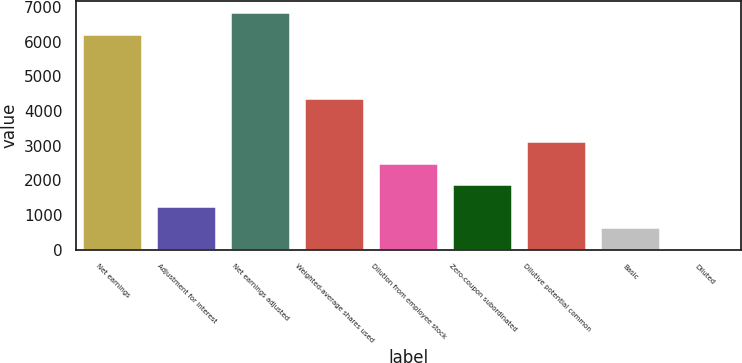Convert chart to OTSL. <chart><loc_0><loc_0><loc_500><loc_500><bar_chart><fcel>Net earnings<fcel>Adjustment for interest<fcel>Net earnings adjusted<fcel>Weighted-average shares used<fcel>Dilution from employee stock<fcel>Zero-coupon subordinated<fcel>Dilutive potential common<fcel>Basic<fcel>Diluted<nl><fcel>6198<fcel>1242.74<fcel>6818.28<fcel>4344.14<fcel>2483.3<fcel>1863.02<fcel>3103.58<fcel>622.46<fcel>2.18<nl></chart> 